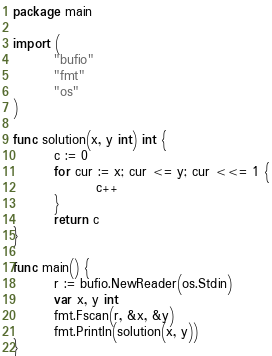Convert code to text. <code><loc_0><loc_0><loc_500><loc_500><_Go_>package main

import (
        "bufio"
        "fmt"
        "os"
)

func solution(x, y int) int {
        c := 0
        for cur := x; cur <= y; cur <<= 1 {
                c++
        }
        return c
}

func main() {
        r := bufio.NewReader(os.Stdin)
        var x, y int
        fmt.Fscan(r, &x, &y)
        fmt.Println(solution(x, y))
}</code> 